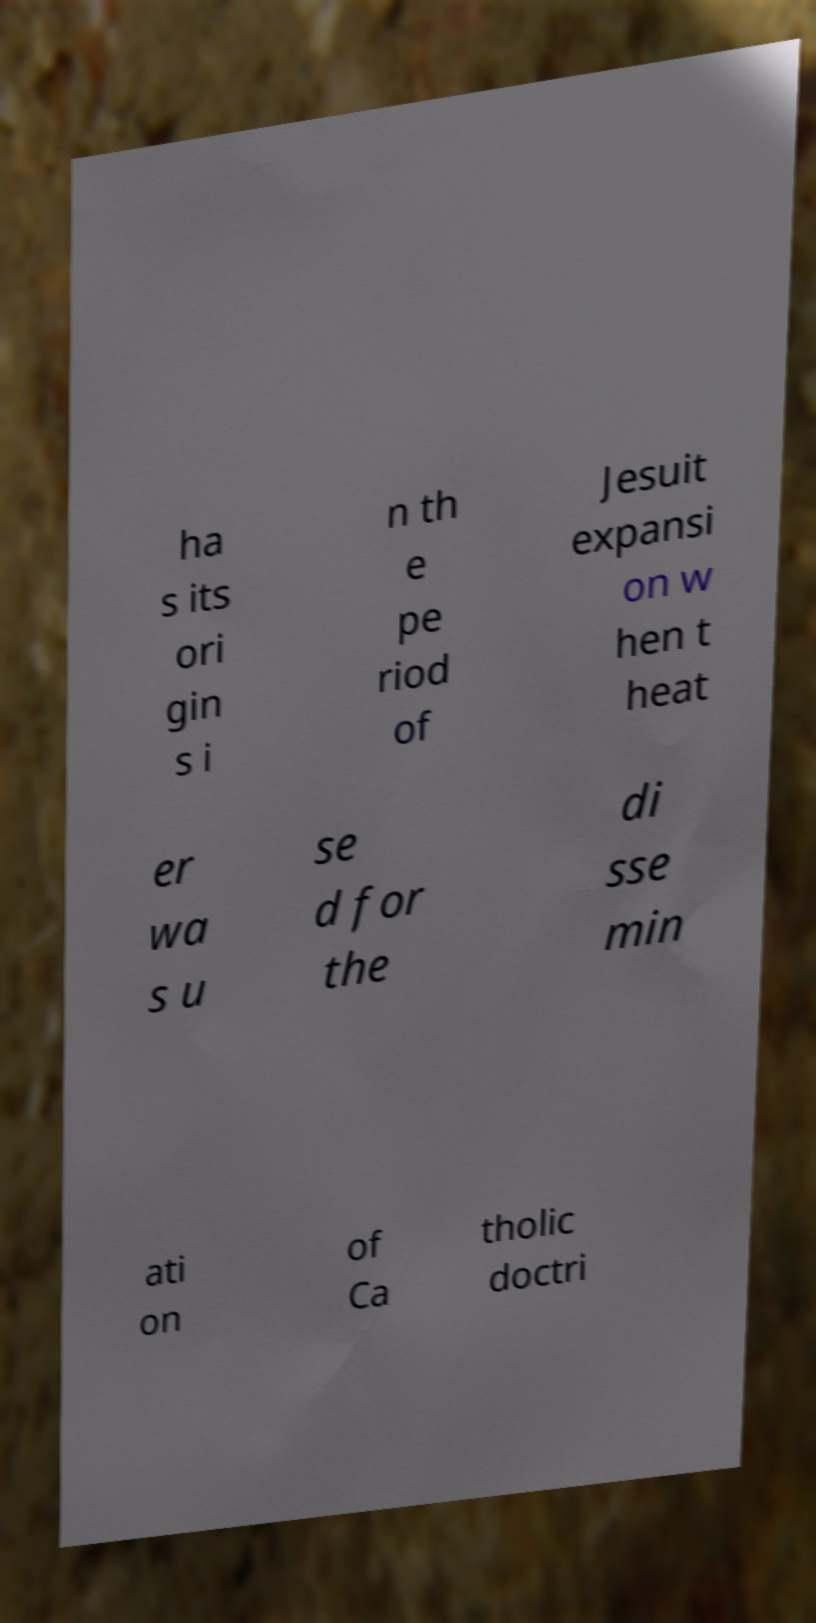Please identify and transcribe the text found in this image. ha s its ori gin s i n th e pe riod of Jesuit expansi on w hen t heat er wa s u se d for the di sse min ati on of Ca tholic doctri 